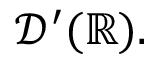<formula> <loc_0><loc_0><loc_500><loc_500>{ \mathcal { D } } ^ { \prime } ( \mathbb { R } ) .</formula> 